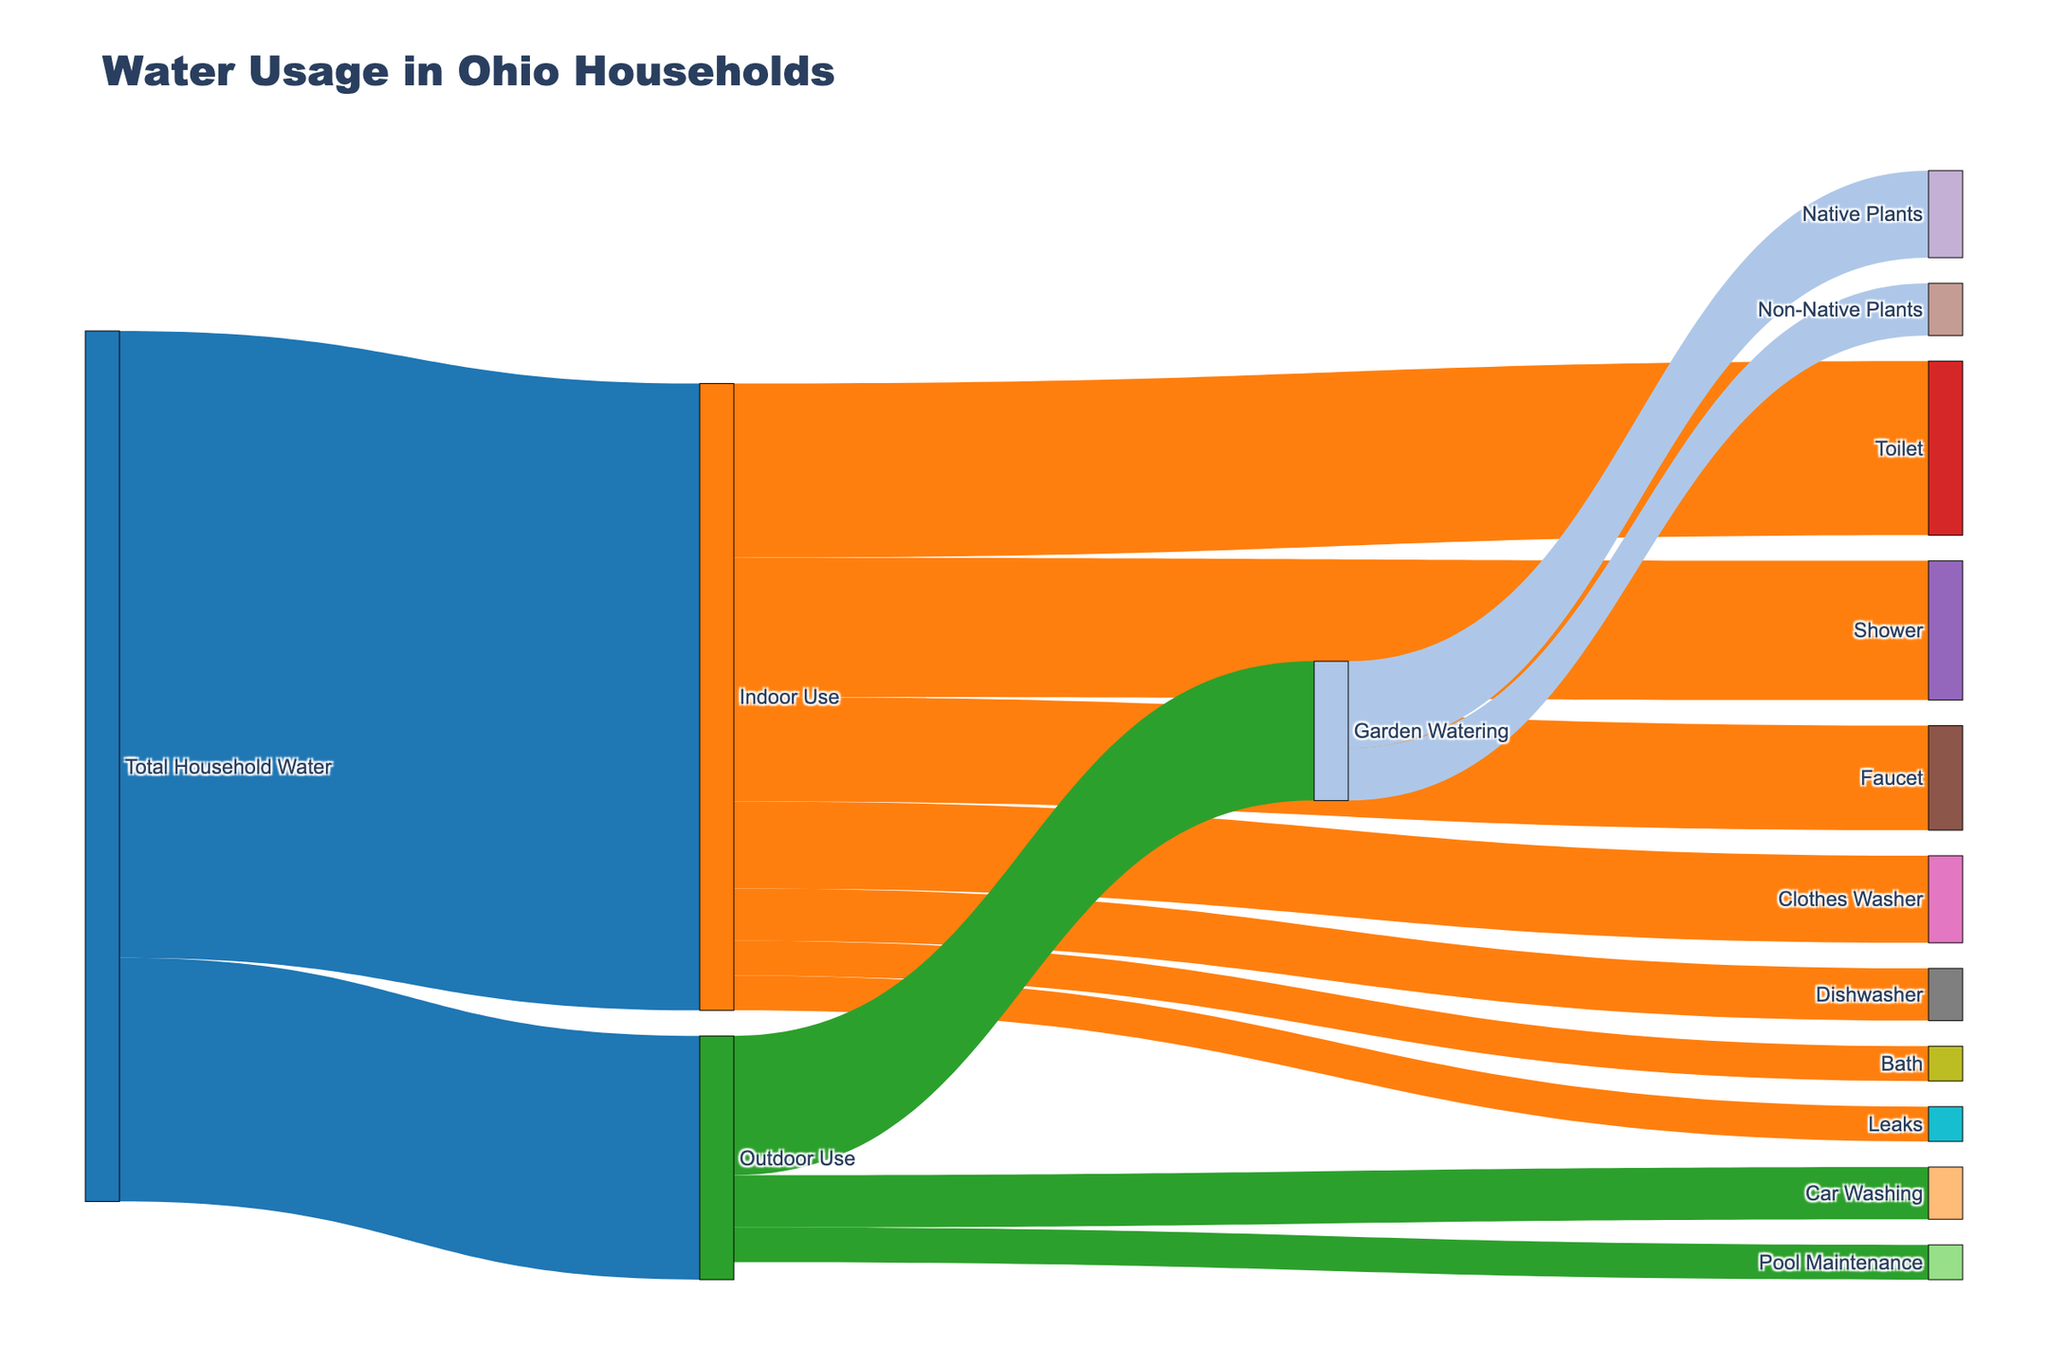What's the total water used for indoor activities? Indoor use in the diagram shows its total value directly, which is the sum of all indoor water usages. Simply locate the "Indoor Use" label connected to "Total Household Water" with a flow value.
Answer: 180 Which activity uses the most water indoors? By examining the links from the "Indoor Use" node to its target activities, identify the activity with the highest value. The "Toilet" has the highest individual value among the indoor activities.
Answer: Toilet How much water is used for gardening non-native plants? Follow the flow from "Outdoor Use" to "Garden Watering" and then from "Garden Watering" to "Non-Native Plants." The label shows the total value for this specific use.
Answer: 15 What's the net water usage for outdoor activities? Outdoor use involves some positive and one negative value due to rainwater collection. Calculate the net water by subtracting the value for "Rainwater Collection" from the sum of positive outdoor usages. The net is 70 - 20 = 50.
Answer: 50 What's the second highest water-consuming activity indoors? After identifying the highest indoor usage under "Toilet," look for the next highest value among the remaining activities linked to "Indoor Use." The "Shower" is the second highest.
Answer: Shower What percentage of the total household water is used for indoor activities? Calculate the percentage by using the ratio of indoor water use to total household water and then multiplying by 100. The formula is (180 / 250) * 100, since the total household water is 180 (indoor) + 70 (outdoor).
Answer: 72% How much less water is used indoors compared to outdoors? Subtract the total value for outdoor use from the total value for indoor use. It is calculated as 180 - 70.
Answer: 110 Is more water used for clothes washing or dishwashing? Compare the values directly linked to "Indoor Use" for "Clothes Washer" and "Dishwasher." "Clothes Washer" has a higher value.
Answer: Clothes Washer How much water is used for native plants compared to non-native plants? Check the values directed towards "Native Plants" and "Non-Native Plants" from "Garden Watering." The values show 25 for native and 15 for non-native plants.
Answer: Native Plants = 25, Non-Native Plants = 15 Is any water saved through rainwater collection? Yes, there is a negative flow value towards "Rainwater Collection," representing water savings. The value is indicated as -20.
Answer: Yes, -20 